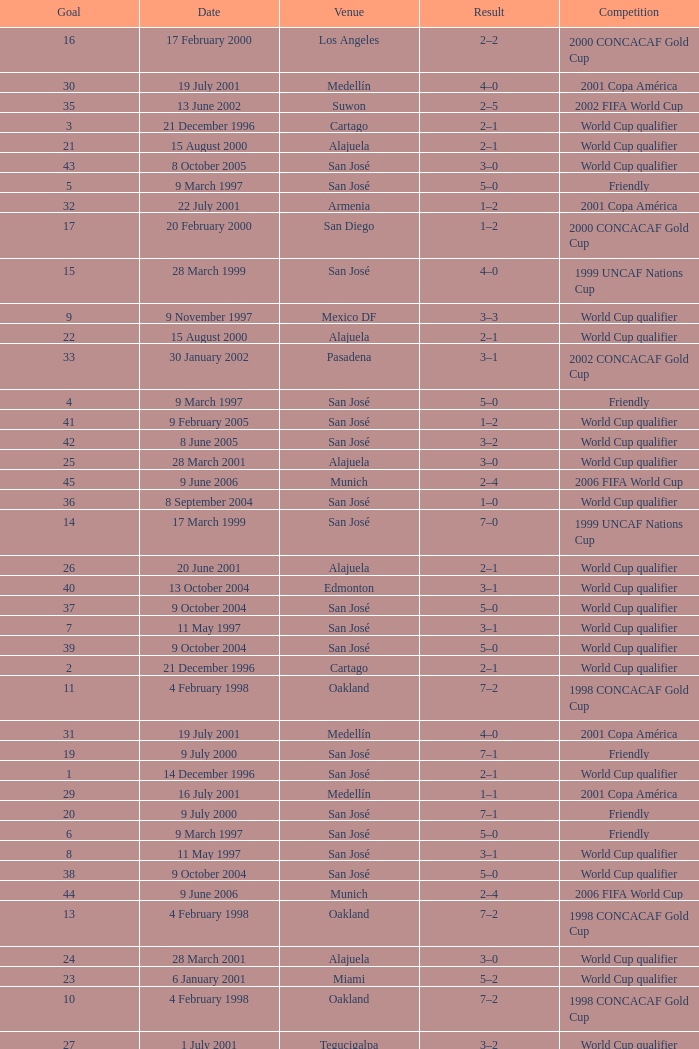I'm looking to parse the entire table for insights. Could you assist me with that? {'header': ['Goal', 'Date', 'Venue', 'Result', 'Competition'], 'rows': [['16', '17 February 2000', 'Los Angeles', '2–2', '2000 CONCACAF Gold Cup'], ['30', '19 July 2001', 'Medellín', '4–0', '2001 Copa América'], ['35', '13 June 2002', 'Suwon', '2–5', '2002 FIFA World Cup'], ['3', '21 December 1996', 'Cartago', '2–1', 'World Cup qualifier'], ['21', '15 August 2000', 'Alajuela', '2–1', 'World Cup qualifier'], ['43', '8 October 2005', 'San José', '3–0', 'World Cup qualifier'], ['5', '9 March 1997', 'San José', '5–0', 'Friendly'], ['32', '22 July 2001', 'Armenia', '1–2', '2001 Copa América'], ['17', '20 February 2000', 'San Diego', '1–2', '2000 CONCACAF Gold Cup'], ['15', '28 March 1999', 'San José', '4–0', '1999 UNCAF Nations Cup'], ['9', '9 November 1997', 'Mexico DF', '3–3', 'World Cup qualifier'], ['22', '15 August 2000', 'Alajuela', '2–1', 'World Cup qualifier'], ['33', '30 January 2002', 'Pasadena', '3–1', '2002 CONCACAF Gold Cup'], ['4', '9 March 1997', 'San José', '5–0', 'Friendly'], ['41', '9 February 2005', 'San José', '1–2', 'World Cup qualifier'], ['42', '8 June 2005', 'San José', '3–2', 'World Cup qualifier'], ['25', '28 March 2001', 'Alajuela', '3–0', 'World Cup qualifier'], ['45', '9 June 2006', 'Munich', '2–4', '2006 FIFA World Cup'], ['36', '8 September 2004', 'San José', '1–0', 'World Cup qualifier'], ['14', '17 March 1999', 'San José', '7–0', '1999 UNCAF Nations Cup'], ['26', '20 June 2001', 'Alajuela', '2–1', 'World Cup qualifier'], ['40', '13 October 2004', 'Edmonton', '3–1', 'World Cup qualifier'], ['37', '9 October 2004', 'San José', '5–0', 'World Cup qualifier'], ['7', '11 May 1997', 'San José', '3–1', 'World Cup qualifier'], ['39', '9 October 2004', 'San José', '5–0', 'World Cup qualifier'], ['2', '21 December 1996', 'Cartago', '2–1', 'World Cup qualifier'], ['11', '4 February 1998', 'Oakland', '7–2', '1998 CONCACAF Gold Cup'], ['31', '19 July 2001', 'Medellín', '4–0', '2001 Copa América'], ['19', '9 July 2000', 'San José', '7–1', 'Friendly'], ['1', '14 December 1996', 'San José', '2–1', 'World Cup qualifier'], ['29', '16 July 2001', 'Medellín', '1–1', '2001 Copa América'], ['20', '9 July 2000', 'San José', '7–1', 'Friendly'], ['6', '9 March 1997', 'San José', '5–0', 'Friendly'], ['8', '11 May 1997', 'San José', '3–1', 'World Cup qualifier'], ['38', '9 October 2004', 'San José', '5–0', 'World Cup qualifier'], ['44', '9 June 2006', 'Munich', '2–4', '2006 FIFA World Cup'], ['13', '4 February 1998', 'Oakland', '7–2', '1998 CONCACAF Gold Cup'], ['24', '28 March 2001', 'Alajuela', '3–0', 'World Cup qualifier'], ['23', '6 January 2001', 'Miami', '5–2', 'World Cup qualifier'], ['10', '4 February 1998', 'Oakland', '7–2', '1998 CONCACAF Gold Cup'], ['27', '1 July 2001', 'Tegucigalpa', '3–2', 'World Cup qualifier'], ['28', '13 July 2001', 'Medellín', '1–0', '2001 Copa América'], ['18', '1 July 2000', 'Alajuela', '5–1', 'Friendly'], ['34', '30 January 2002', 'Pasadena', '3–1', '2002 CONCACAF Gold Cup'], ['12', '4 February 1998', 'Oakland', '7–2', '1998 CONCACAF Gold Cup']]} What is the result in oakland? 7–2, 7–2, 7–2, 7–2. 